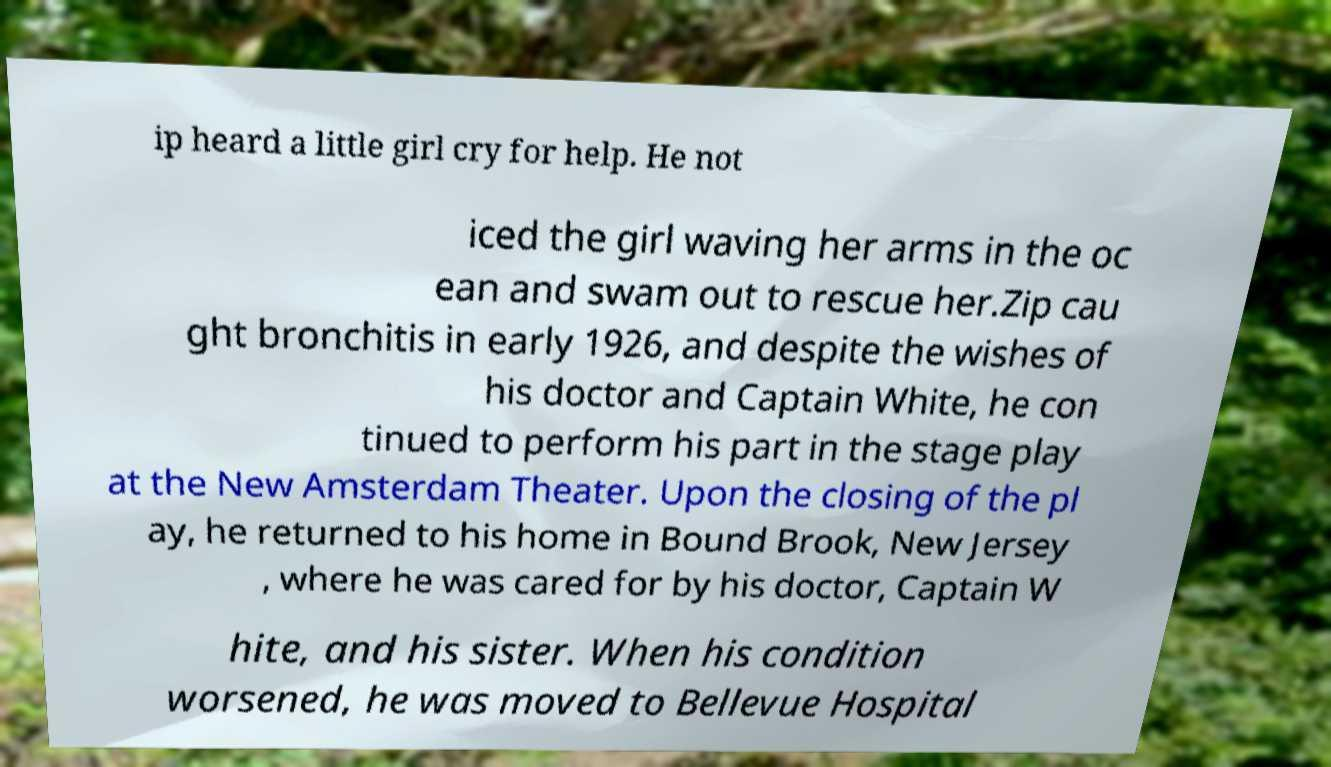There's text embedded in this image that I need extracted. Can you transcribe it verbatim? ip heard a little girl cry for help. He not iced the girl waving her arms in the oc ean and swam out to rescue her.Zip cau ght bronchitis in early 1926, and despite the wishes of his doctor and Captain White, he con tinued to perform his part in the stage play at the New Amsterdam Theater. Upon the closing of the pl ay, he returned to his home in Bound Brook, New Jersey , where he was cared for by his doctor, Captain W hite, and his sister. When his condition worsened, he was moved to Bellevue Hospital 